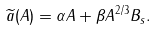<formula> <loc_0><loc_0><loc_500><loc_500>\widetilde { a } ( A ) = \alpha A + \beta A ^ { 2 / 3 } B _ { s } .</formula> 